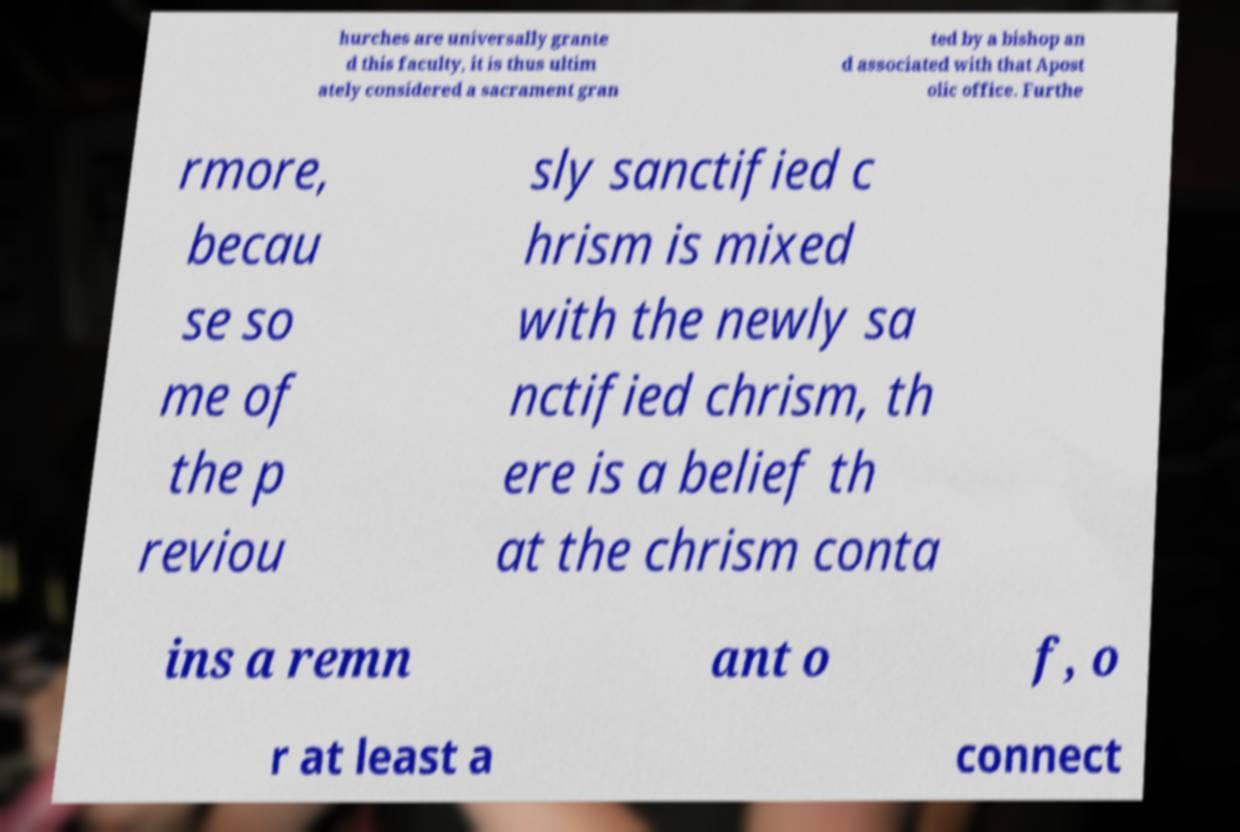Can you accurately transcribe the text from the provided image for me? hurches are universally grante d this faculty, it is thus ultim ately considered a sacrament gran ted by a bishop an d associated with that Apost olic office. Furthe rmore, becau se so me of the p reviou sly sanctified c hrism is mixed with the newly sa nctified chrism, th ere is a belief th at the chrism conta ins a remn ant o f, o r at least a connect 